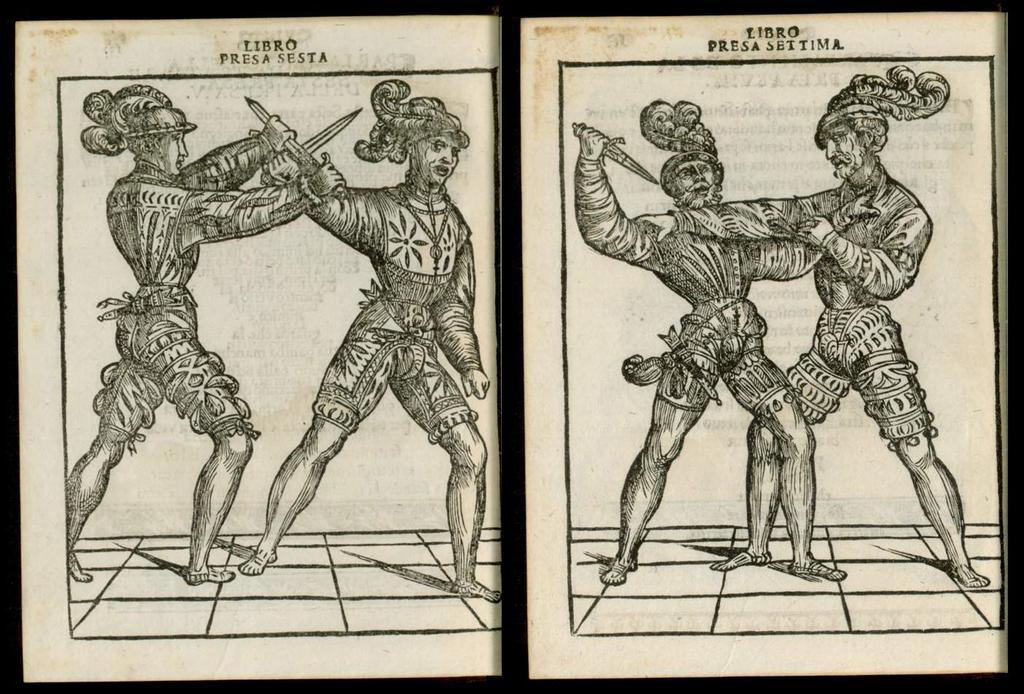Can you describe this image briefly? In this image I see a sketch, in which there are 4 persons and 3 of them are holding knives. 